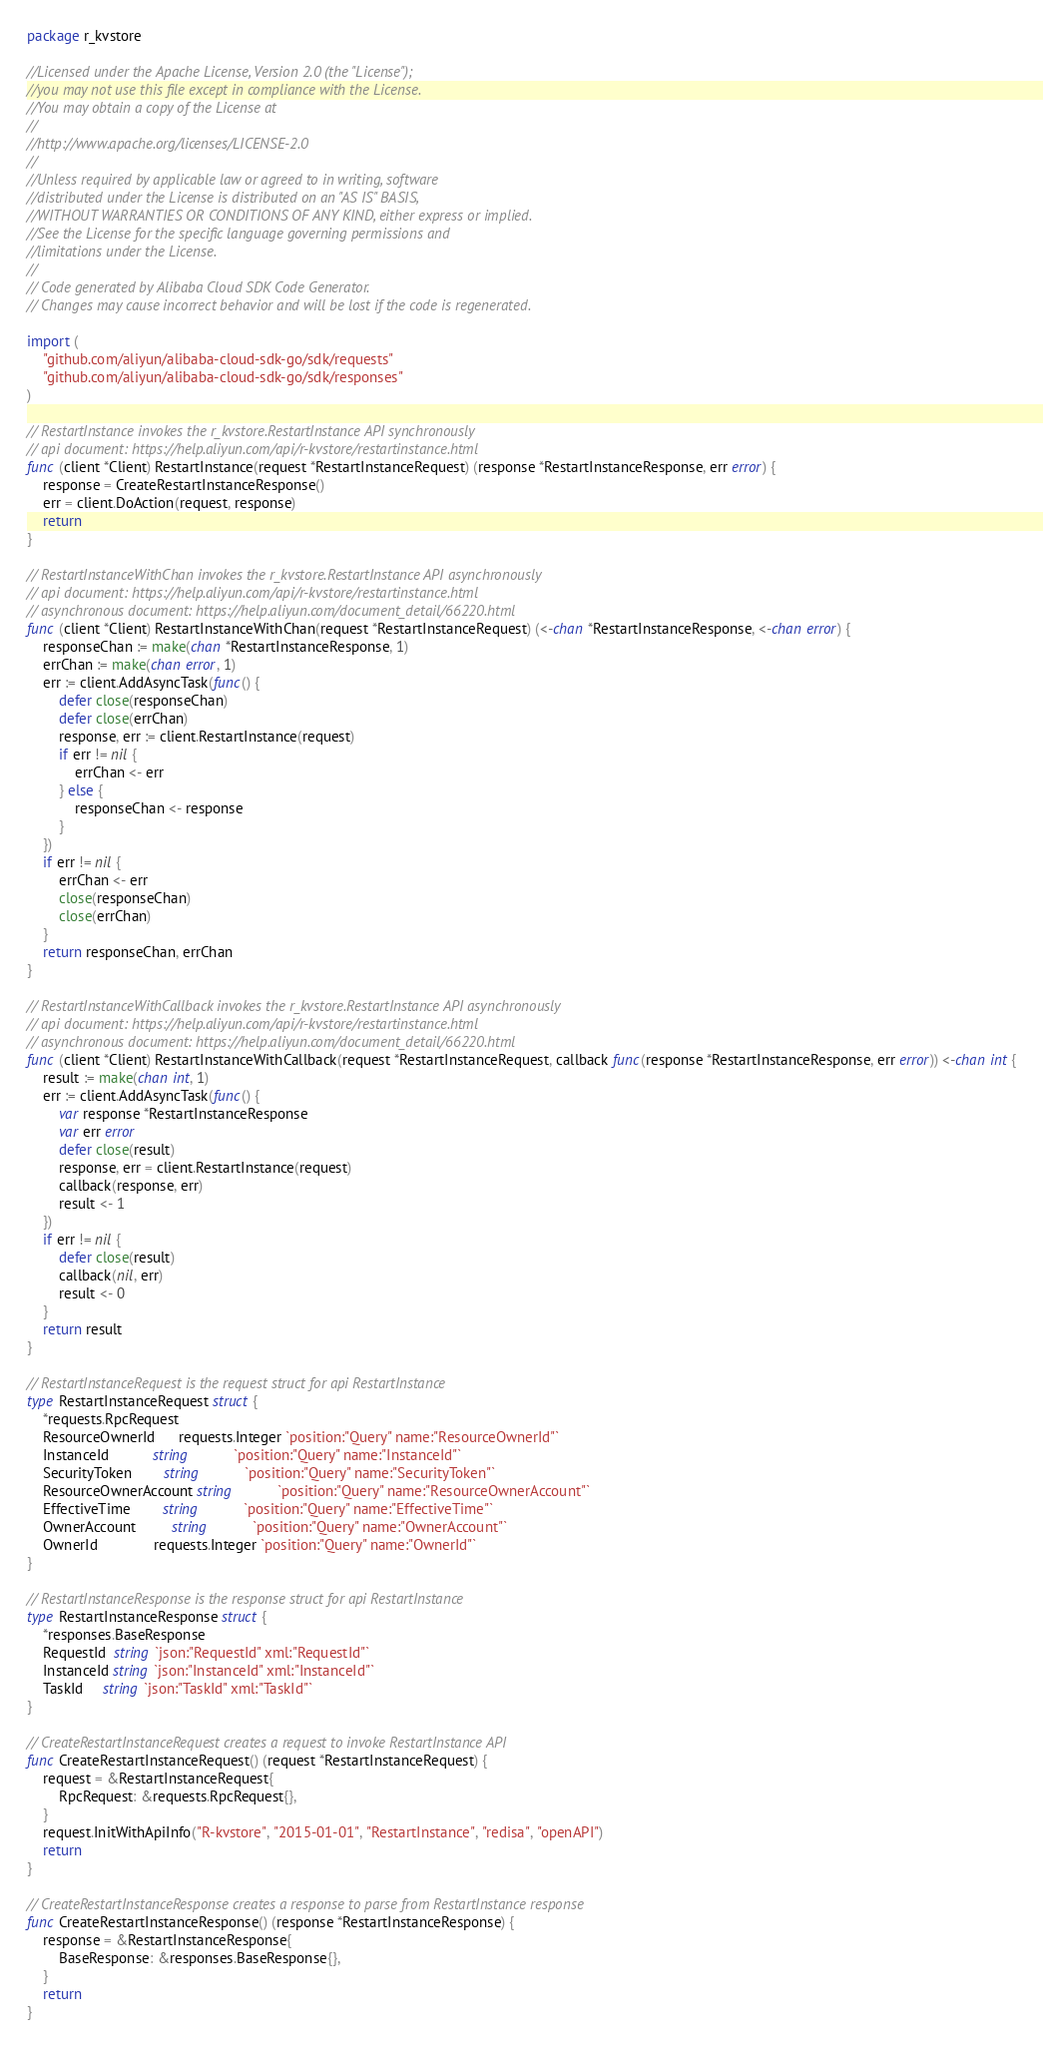<code> <loc_0><loc_0><loc_500><loc_500><_Go_>package r_kvstore

//Licensed under the Apache License, Version 2.0 (the "License");
//you may not use this file except in compliance with the License.
//You may obtain a copy of the License at
//
//http://www.apache.org/licenses/LICENSE-2.0
//
//Unless required by applicable law or agreed to in writing, software
//distributed under the License is distributed on an "AS IS" BASIS,
//WITHOUT WARRANTIES OR CONDITIONS OF ANY KIND, either express or implied.
//See the License for the specific language governing permissions and
//limitations under the License.
//
// Code generated by Alibaba Cloud SDK Code Generator.
// Changes may cause incorrect behavior and will be lost if the code is regenerated.

import (
	"github.com/aliyun/alibaba-cloud-sdk-go/sdk/requests"
	"github.com/aliyun/alibaba-cloud-sdk-go/sdk/responses"
)

// RestartInstance invokes the r_kvstore.RestartInstance API synchronously
// api document: https://help.aliyun.com/api/r-kvstore/restartinstance.html
func (client *Client) RestartInstance(request *RestartInstanceRequest) (response *RestartInstanceResponse, err error) {
	response = CreateRestartInstanceResponse()
	err = client.DoAction(request, response)
	return
}

// RestartInstanceWithChan invokes the r_kvstore.RestartInstance API asynchronously
// api document: https://help.aliyun.com/api/r-kvstore/restartinstance.html
// asynchronous document: https://help.aliyun.com/document_detail/66220.html
func (client *Client) RestartInstanceWithChan(request *RestartInstanceRequest) (<-chan *RestartInstanceResponse, <-chan error) {
	responseChan := make(chan *RestartInstanceResponse, 1)
	errChan := make(chan error, 1)
	err := client.AddAsyncTask(func() {
		defer close(responseChan)
		defer close(errChan)
		response, err := client.RestartInstance(request)
		if err != nil {
			errChan <- err
		} else {
			responseChan <- response
		}
	})
	if err != nil {
		errChan <- err
		close(responseChan)
		close(errChan)
	}
	return responseChan, errChan
}

// RestartInstanceWithCallback invokes the r_kvstore.RestartInstance API asynchronously
// api document: https://help.aliyun.com/api/r-kvstore/restartinstance.html
// asynchronous document: https://help.aliyun.com/document_detail/66220.html
func (client *Client) RestartInstanceWithCallback(request *RestartInstanceRequest, callback func(response *RestartInstanceResponse, err error)) <-chan int {
	result := make(chan int, 1)
	err := client.AddAsyncTask(func() {
		var response *RestartInstanceResponse
		var err error
		defer close(result)
		response, err = client.RestartInstance(request)
		callback(response, err)
		result <- 1
	})
	if err != nil {
		defer close(result)
		callback(nil, err)
		result <- 0
	}
	return result
}

// RestartInstanceRequest is the request struct for api RestartInstance
type RestartInstanceRequest struct {
	*requests.RpcRequest
	ResourceOwnerId      requests.Integer `position:"Query" name:"ResourceOwnerId"`
	InstanceId           string           `position:"Query" name:"InstanceId"`
	SecurityToken        string           `position:"Query" name:"SecurityToken"`
	ResourceOwnerAccount string           `position:"Query" name:"ResourceOwnerAccount"`
	EffectiveTime        string           `position:"Query" name:"EffectiveTime"`
	OwnerAccount         string           `position:"Query" name:"OwnerAccount"`
	OwnerId              requests.Integer `position:"Query" name:"OwnerId"`
}

// RestartInstanceResponse is the response struct for api RestartInstance
type RestartInstanceResponse struct {
	*responses.BaseResponse
	RequestId  string `json:"RequestId" xml:"RequestId"`
	InstanceId string `json:"InstanceId" xml:"InstanceId"`
	TaskId     string `json:"TaskId" xml:"TaskId"`
}

// CreateRestartInstanceRequest creates a request to invoke RestartInstance API
func CreateRestartInstanceRequest() (request *RestartInstanceRequest) {
	request = &RestartInstanceRequest{
		RpcRequest: &requests.RpcRequest{},
	}
	request.InitWithApiInfo("R-kvstore", "2015-01-01", "RestartInstance", "redisa", "openAPI")
	return
}

// CreateRestartInstanceResponse creates a response to parse from RestartInstance response
func CreateRestartInstanceResponse() (response *RestartInstanceResponse) {
	response = &RestartInstanceResponse{
		BaseResponse: &responses.BaseResponse{},
	}
	return
}
</code> 